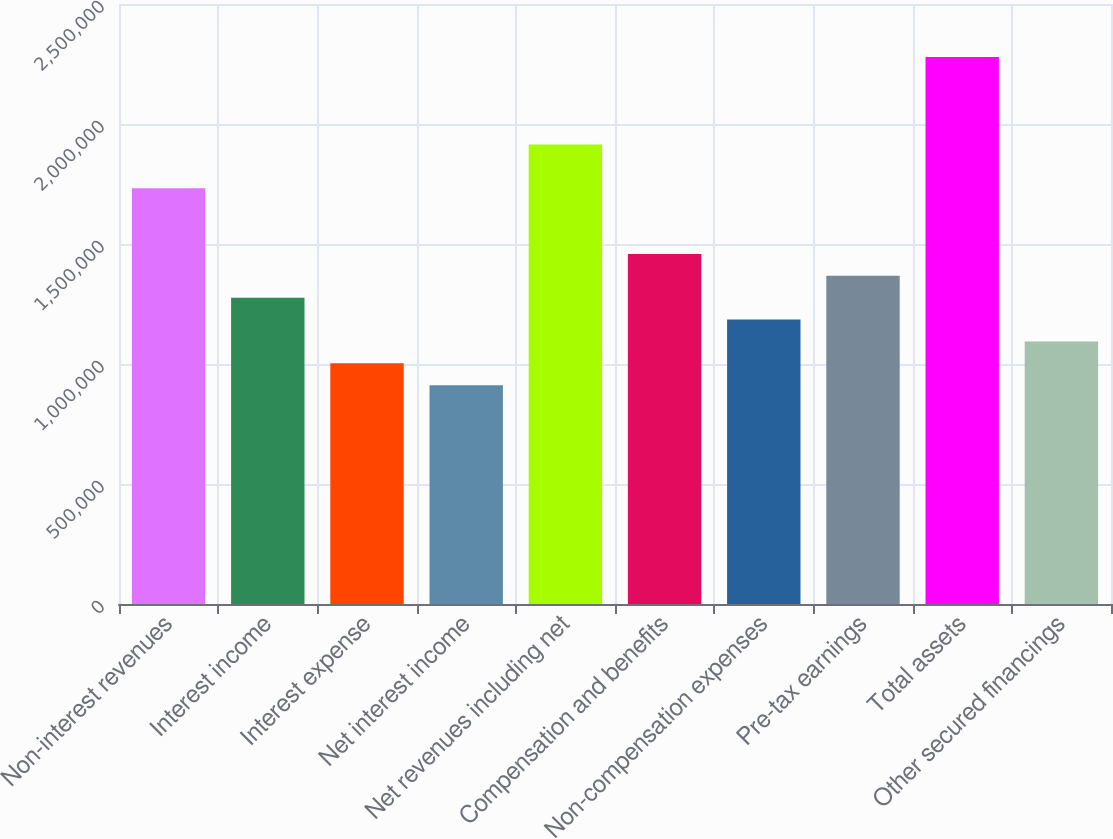Convert chart to OTSL. <chart><loc_0><loc_0><loc_500><loc_500><bar_chart><fcel>Non-interest revenues<fcel>Interest income<fcel>Interest expense<fcel>Net interest income<fcel>Net revenues including net<fcel>Compensation and benefits<fcel>Non-compensation expenses<fcel>Pre-tax earnings<fcel>Total assets<fcel>Other secured financings<nl><fcel>1.73186e+06<fcel>1.27611e+06<fcel>1.00266e+06<fcel>911507<fcel>1.91416e+06<fcel>1.45841e+06<fcel>1.18496e+06<fcel>1.36726e+06<fcel>2.27876e+06<fcel>1.09381e+06<nl></chart> 